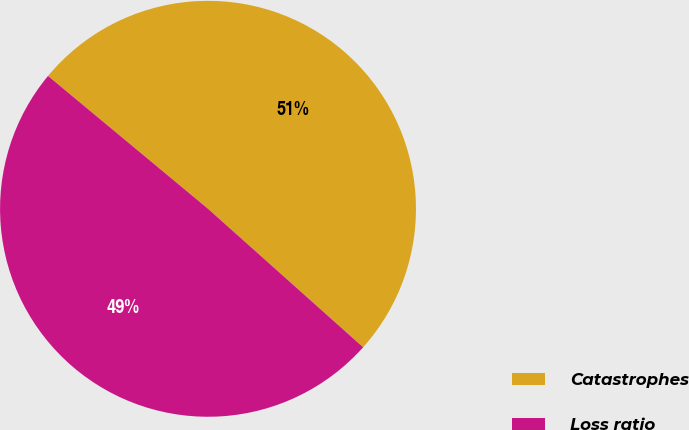<chart> <loc_0><loc_0><loc_500><loc_500><pie_chart><fcel>Catastrophes<fcel>Loss ratio<nl><fcel>50.57%<fcel>49.43%<nl></chart> 